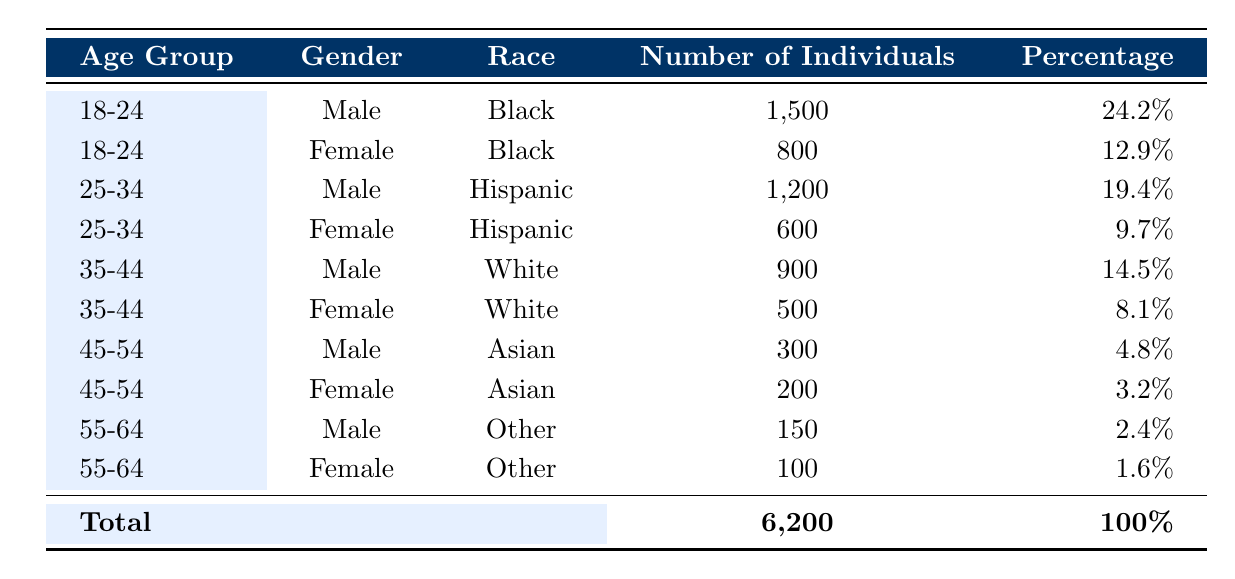What is the total number of individuals affected by bail decisions? To find the total number of individuals, we refer to the last row of the table where it states "Total" in the "Number of Individuals" column. It shows the total as 6,200.
Answer: 6200 Which demographic group has the highest representation among individuals affected by bail decisions? Looking at the "Number of Individuals" column, the highest number is for "Male" in the "18-24" age group with 1,500 individuals.
Answer: Male, 18-24 How many females aged 25-34 are affected by bail decisions? By examining the "25-34" age group under the "Female" category in the table, we see there are 600 individuals.
Answer: 600 What is the percentage of males aged 35-44 affected by bail decisions? We find "900" individuals in the "35-44" age group who are male. The percentage is listed as 14.5% in the table.
Answer: 14.5% Is there a higher number of Black males or Black females affected by bail decisions? Black males have 1,500 individuals, and Black females have 800 individuals. Since 1,500 is greater than 800, Black males are higher.
Answer: Yes What is the total number of individuals aged 45-54 affected by bail decisions? Adding the males (300) and females (200) in the "45-54" age group together gives us 300 + 200 = 500.
Answer: 500 How many more Hispanic males than Hispanic females are affected by bail decisions? Hispanic males number 1,200, while Hispanic females are 600. We subtract the two: 1,200 - 600 = 600.
Answer: 600 What proportion of individuals affected by bail decisions are Asian? The number of Asians is 300 (male) + 200 (female) = 500. To find the proportion, we take 500 and divide by the total 6,200: 500 / 6,200 = approximately 0.0806 or 8.06%.
Answer: 8.06% Are there more males or females affected in the age group 55-64? In the "55-64" age group, males accounted for 150 individuals and females for 100 individuals. Since 150 is greater than 100, males are higher.
Answer: Yes 